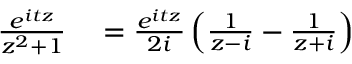Convert formula to latex. <formula><loc_0><loc_0><loc_500><loc_500>\begin{array} { r l } { { \frac { e ^ { i t z } } { z ^ { 2 } + 1 } } } & = { \frac { e ^ { i t z } } { 2 i } } \left ( { \frac { 1 } { z - i } } - { \frac { 1 } { z + i } } \right ) } \end{array}</formula> 